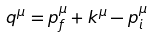<formula> <loc_0><loc_0><loc_500><loc_500>q ^ { \mu } = p _ { f } ^ { \mu } + k ^ { \mu } - p _ { i } ^ { \mu }</formula> 